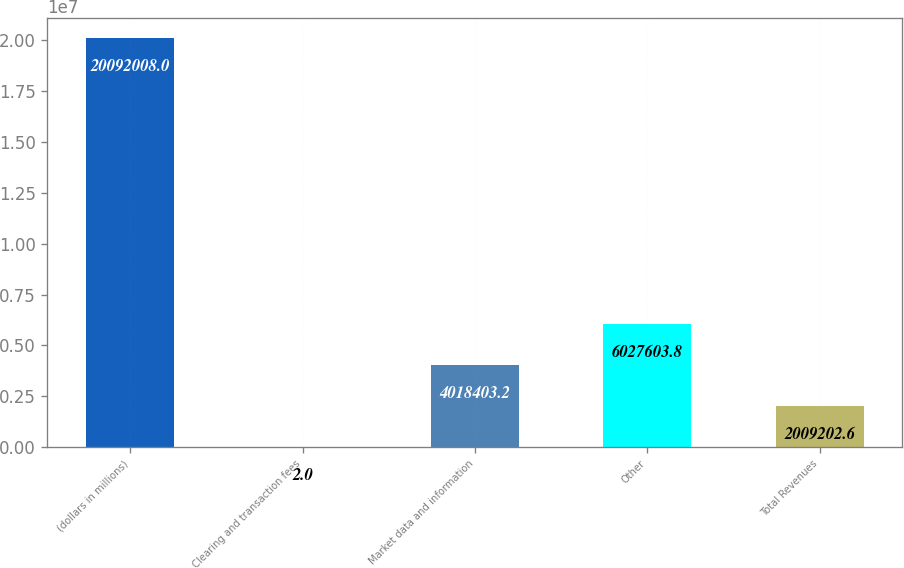Convert chart. <chart><loc_0><loc_0><loc_500><loc_500><bar_chart><fcel>(dollars in millions)<fcel>Clearing and transaction fees<fcel>Market data and information<fcel>Other<fcel>Total Revenues<nl><fcel>2.0092e+07<fcel>2<fcel>4.0184e+06<fcel>6.0276e+06<fcel>2.0092e+06<nl></chart> 